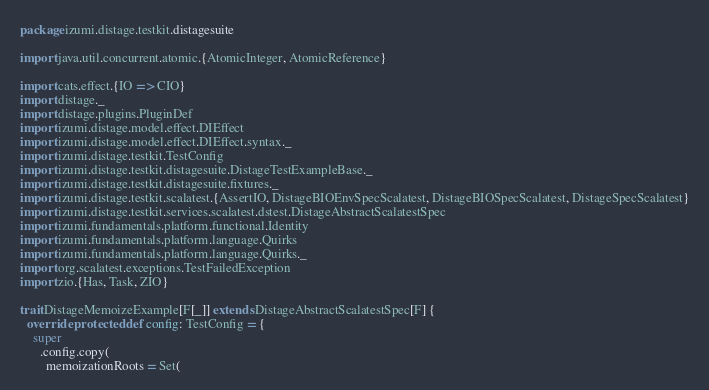Convert code to text. <code><loc_0><loc_0><loc_500><loc_500><_Scala_>package izumi.distage.testkit.distagesuite

import java.util.concurrent.atomic.{AtomicInteger, AtomicReference}

import cats.effect.{IO => CIO}
import distage._
import distage.plugins.PluginDef
import izumi.distage.model.effect.DIEffect
import izumi.distage.model.effect.DIEffect.syntax._
import izumi.distage.testkit.TestConfig
import izumi.distage.testkit.distagesuite.DistageTestExampleBase._
import izumi.distage.testkit.distagesuite.fixtures._
import izumi.distage.testkit.scalatest.{AssertIO, DistageBIOEnvSpecScalatest, DistageBIOSpecScalatest, DistageSpecScalatest}
import izumi.distage.testkit.services.scalatest.dstest.DistageAbstractScalatestSpec
import izumi.fundamentals.platform.functional.Identity
import izumi.fundamentals.platform.language.Quirks
import izumi.fundamentals.platform.language.Quirks._
import org.scalatest.exceptions.TestFailedException
import zio.{Has, Task, ZIO}

trait DistageMemoizeExample[F[_]] extends DistageAbstractScalatestSpec[F] {
  override protected def config: TestConfig = {
    super
      .config.copy(
        memoizationRoots = Set(</code> 